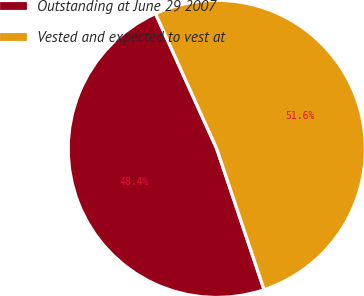Convert chart. <chart><loc_0><loc_0><loc_500><loc_500><pie_chart><fcel>Outstanding at June 29 2007<fcel>Vested and expected to vest at<nl><fcel>48.39%<fcel>51.61%<nl></chart> 